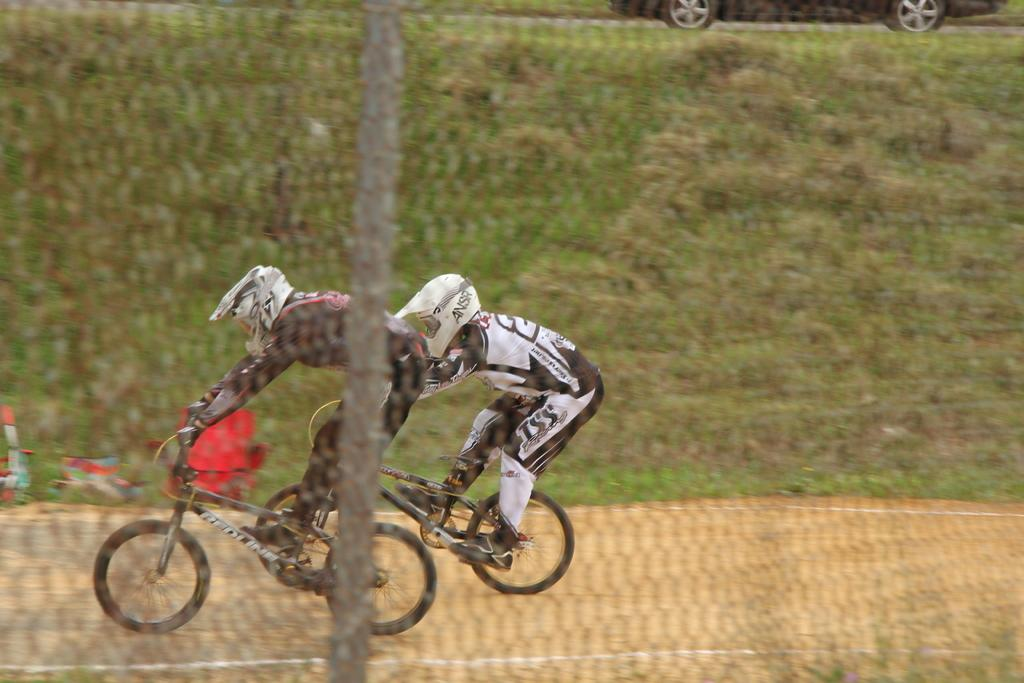What are the two persons in the image doing? The two persons in the image are riding bicycles. What can be seen in the background of the image? There is grass in the background of the image. What other mode of transportation is present in the image? There is a car in the image. What is located in the foreground of the image? There is a net in the foreground of the image. What is the opinion of the downtown area in the image? There is no reference to a downtown area or any opinions in the image. 